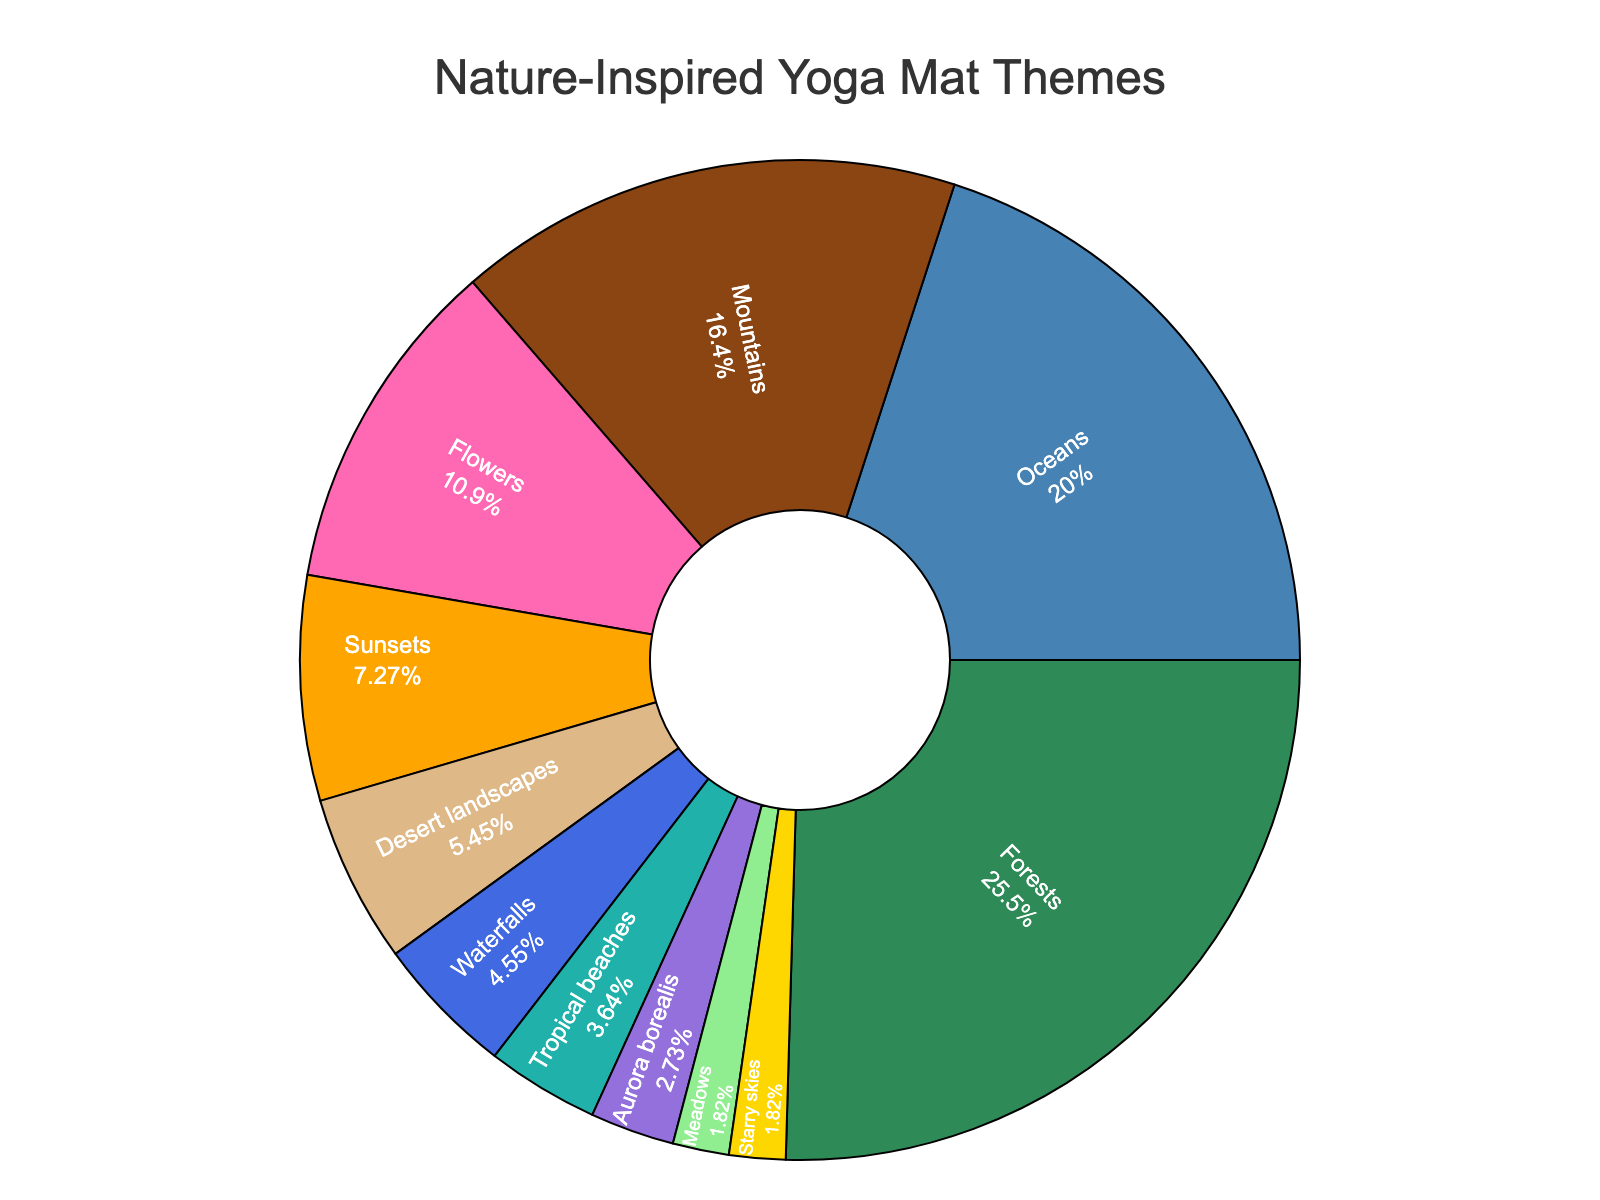Which theme has the highest percentage of sales? By observing the figure, the theme with the largest segment is labeled "Forests" with 28%.
Answer: Forests How much greater is the sales percentage of Oceans compared to Sunsets? The Oceans segment is 22%, and the Sunsets segment is 8%. The difference is calculated as 22% - 8% = 14%.
Answer: 14% Which themes have sales percentages less than 5%? By visually identifying the segments with percentages less than 5%, we see "Aurora borealis," "Meadows," "Starry skies," and "Tropical beaches."
Answer: Aurora borealis, Meadows, Starry skies, Tropical beaches What is the total sales percentage for Mountains, Flowers, and Sunsets combined? The percentages for Mountains, Flowers, and Sunsets are 18%, 12%, and 8%, respectively. Summing these values gives 18% + 12% + 8% = 38%.
Answer: 38% Which theme uses the pink color in the pie chart? By observing the visual attributes of the segments, the pink-colored segment corresponds to "Flowers."
Answer: Flowers What is the combined sales percentage for the themes with sales below 10%? The themes with sales below 10% are Sunsets (8%), Desert landscapes (6%), Waterfalls (5%), Tropical beaches (4%), Aurora borealis (3%), Meadows (2%), and Starry skies (2%). Adding these values gives 8% + 6% + 5% + 4% + 3% + 2% + 2% = 30%.
Answer: 30% Is the percentage of sales for Waterfalls greater than that for Meadows and Starry skies combined? Waterfalls have a 5% sales percentage while Meadows and Starry skies combine to 2% + 2% = 4%. Since 5% > 4%, the sales percentage for Waterfalls is indeed greater.
Answer: Yes What is the average sales percentage for the top three themes? The top three themes are Forests (28%), Oceans (22%), and Mountains (18%). The average is calculated as (28% + 22% + 18%) / 3 = 68% / 3 ≈ 22.67%.
Answer: 22.67% Which theme has the smallest sales percentage, and what is that percentage? The smallest segment in the pie chart, labeled "Meadows" and "Starry skies", both have a percentage of 2%.
Answer: Meadows, Starry skies, 2% Among the themes with a sales percentage of 6% or higher, which theme has the lowest percentage? The themes with a sales percentage of 6% or higher are Forests (28%), Oceans (22%), Mountains (18%), Flowers (12%), Sunsets (8%), and Desert landscapes (6%). The lowest among these is Desert landscapes at 6%.
Answer: Desert landscapes 